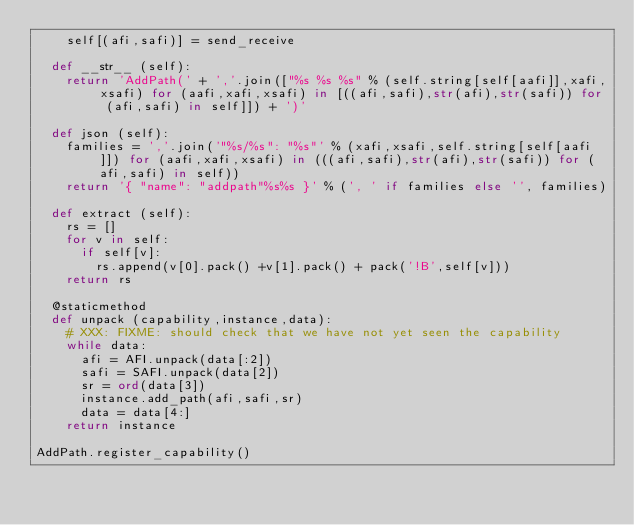<code> <loc_0><loc_0><loc_500><loc_500><_Python_>		self[(afi,safi)] = send_receive

	def __str__ (self):
		return 'AddPath(' + ','.join(["%s %s %s" % (self.string[self[aafi]],xafi,xsafi) for (aafi,xafi,xsafi) in [((afi,safi),str(afi),str(safi)) for (afi,safi) in self]]) + ')'

	def json (self):
		families = ','.join('"%s/%s": "%s"' % (xafi,xsafi,self.string[self[aafi]]) for (aafi,xafi,xsafi) in (((afi,safi),str(afi),str(safi)) for (afi,safi) in self))
		return '{ "name": "addpath"%s%s }' % (', ' if families else '', families)

	def extract (self):
		rs = []
		for v in self:
			if self[v]:
				rs.append(v[0].pack() +v[1].pack() + pack('!B',self[v]))
		return rs

	@staticmethod
	def unpack (capability,instance,data):
		# XXX: FIXME: should check that we have not yet seen the capability
		while data:
			afi = AFI.unpack(data[:2])
			safi = SAFI.unpack(data[2])
			sr = ord(data[3])
			instance.add_path(afi,safi,sr)
			data = data[4:]
		return instance

AddPath.register_capability()
</code> 